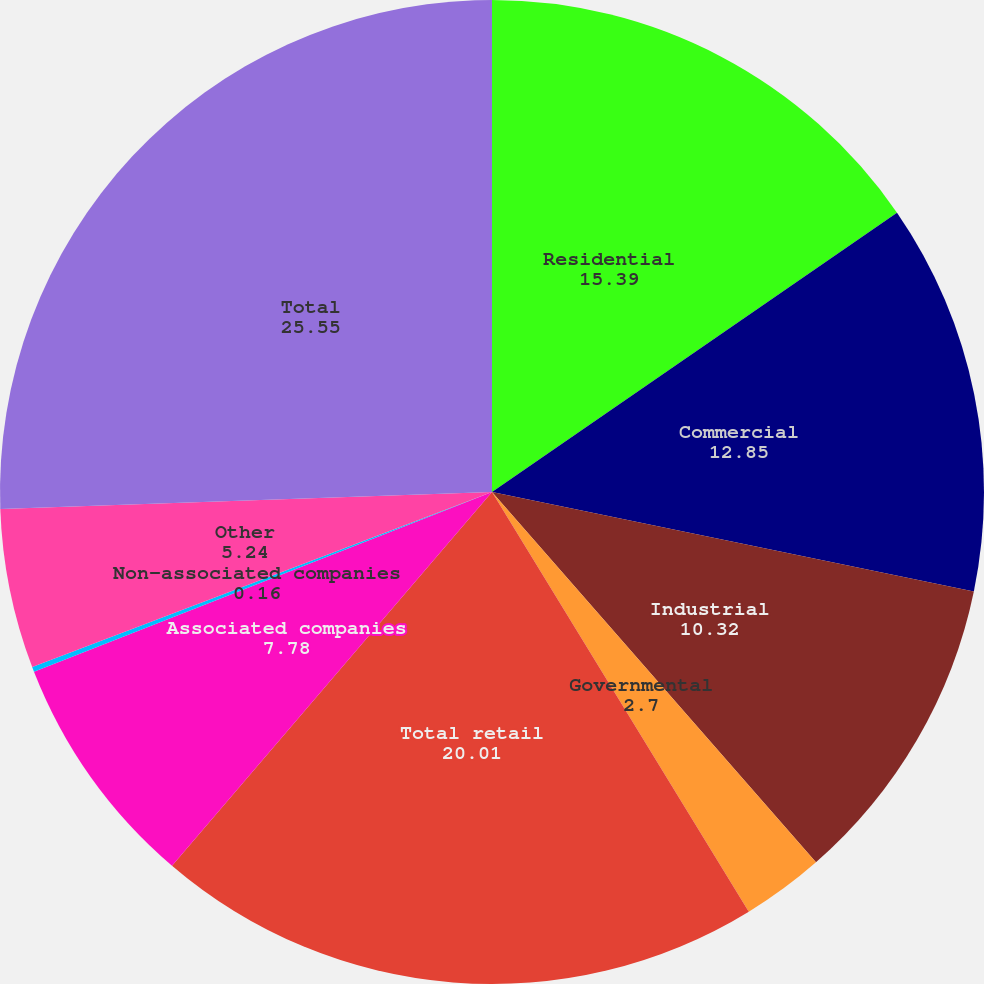<chart> <loc_0><loc_0><loc_500><loc_500><pie_chart><fcel>Residential<fcel>Commercial<fcel>Industrial<fcel>Governmental<fcel>Total retail<fcel>Associated companies<fcel>Non-associated companies<fcel>Other<fcel>Total<nl><fcel>15.39%<fcel>12.85%<fcel>10.32%<fcel>2.7%<fcel>20.01%<fcel>7.78%<fcel>0.16%<fcel>5.24%<fcel>25.55%<nl></chart> 